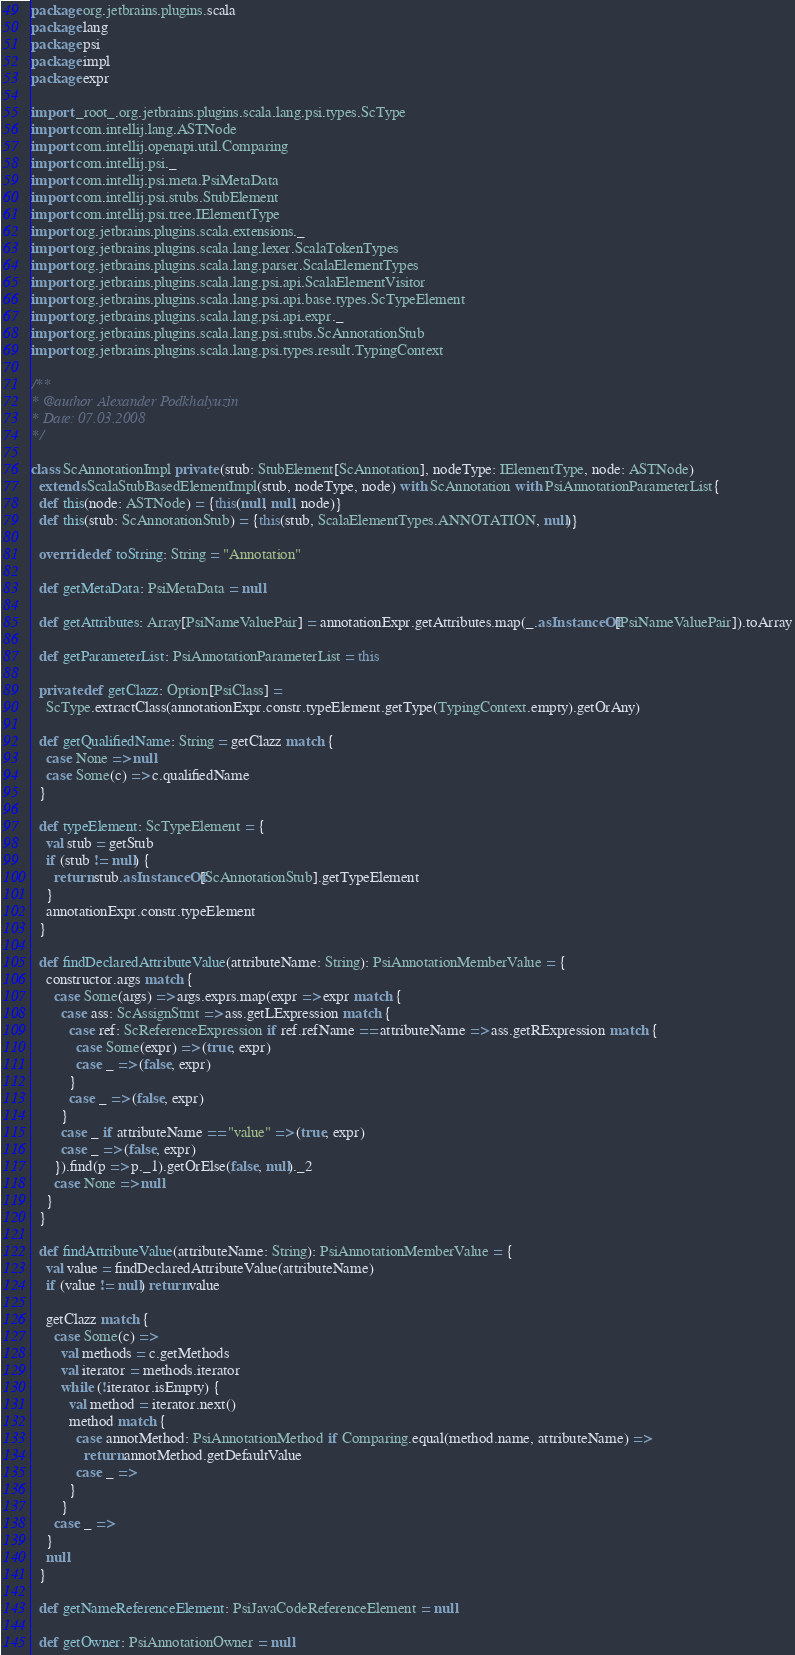<code> <loc_0><loc_0><loc_500><loc_500><_Scala_>package org.jetbrains.plugins.scala
package lang
package psi
package impl
package expr

import _root_.org.jetbrains.plugins.scala.lang.psi.types.ScType
import com.intellij.lang.ASTNode
import com.intellij.openapi.util.Comparing
import com.intellij.psi._
import com.intellij.psi.meta.PsiMetaData
import com.intellij.psi.stubs.StubElement
import com.intellij.psi.tree.IElementType
import org.jetbrains.plugins.scala.extensions._
import org.jetbrains.plugins.scala.lang.lexer.ScalaTokenTypes
import org.jetbrains.plugins.scala.lang.parser.ScalaElementTypes
import org.jetbrains.plugins.scala.lang.psi.api.ScalaElementVisitor
import org.jetbrains.plugins.scala.lang.psi.api.base.types.ScTypeElement
import org.jetbrains.plugins.scala.lang.psi.api.expr._
import org.jetbrains.plugins.scala.lang.psi.stubs.ScAnnotationStub
import org.jetbrains.plugins.scala.lang.psi.types.result.TypingContext

/**
* @author Alexander Podkhalyuzin
* Date: 07.03.2008
*/

class ScAnnotationImpl private (stub: StubElement[ScAnnotation], nodeType: IElementType, node: ASTNode)
  extends ScalaStubBasedElementImpl(stub, nodeType, node) with ScAnnotation with PsiAnnotationParameterList{
  def this(node: ASTNode) = {this(null, null, node)}
  def this(stub: ScAnnotationStub) = {this(stub, ScalaElementTypes.ANNOTATION, null)}

  override def toString: String = "Annotation"

  def getMetaData: PsiMetaData = null

  def getAttributes: Array[PsiNameValuePair] = annotationExpr.getAttributes.map(_.asInstanceOf[PsiNameValuePair]).toArray

  def getParameterList: PsiAnnotationParameterList = this

  private def getClazz: Option[PsiClass] =
    ScType.extractClass(annotationExpr.constr.typeElement.getType(TypingContext.empty).getOrAny)

  def getQualifiedName: String = getClazz match {
    case None => null
    case Some(c) => c.qualifiedName
  }

  def typeElement: ScTypeElement = {
    val stub = getStub
    if (stub != null) {
      return stub.asInstanceOf[ScAnnotationStub].getTypeElement
    }
    annotationExpr.constr.typeElement
  }

  def findDeclaredAttributeValue(attributeName: String): PsiAnnotationMemberValue = {
    constructor.args match {
      case Some(args) => args.exprs.map(expr => expr match {
        case ass: ScAssignStmt => ass.getLExpression match {
          case ref: ScReferenceExpression if ref.refName == attributeName => ass.getRExpression match {
            case Some(expr) => (true, expr)
            case _ => (false, expr)
          }
          case _ => (false, expr)
        }
        case _ if attributeName == "value" => (true, expr)
        case _ => (false, expr)
      }).find(p => p._1).getOrElse(false, null)._2
      case None => null
    }
  }

  def findAttributeValue(attributeName: String): PsiAnnotationMemberValue = {
    val value = findDeclaredAttributeValue(attributeName)
    if (value != null) return value

    getClazz match {
      case Some(c) =>
        val methods = c.getMethods
        val iterator = methods.iterator
        while (!iterator.isEmpty) {
          val method = iterator.next()
          method match {
            case annotMethod: PsiAnnotationMethod if Comparing.equal(method.name, attributeName) =>
              return annotMethod.getDefaultValue
            case _ =>
          }
        }
      case _ =>
    }
    null
  }

  def getNameReferenceElement: PsiJavaCodeReferenceElement = null

  def getOwner: PsiAnnotationOwner = null
</code> 